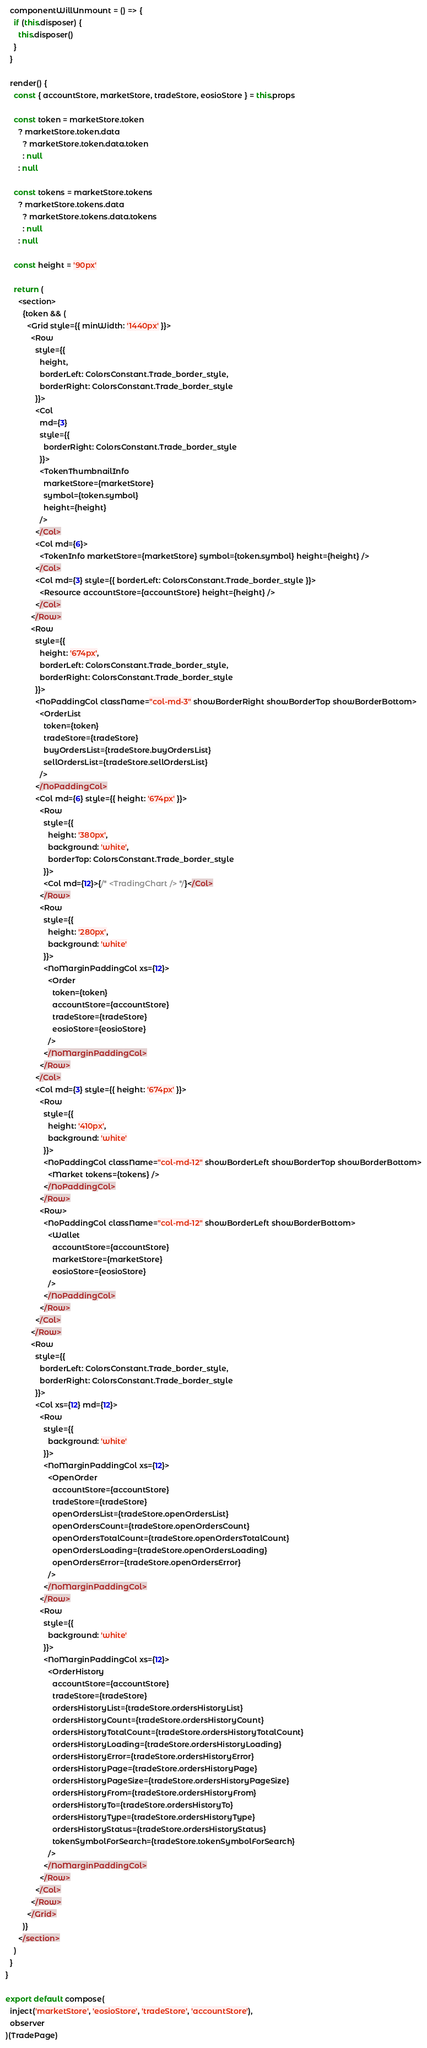Convert code to text. <code><loc_0><loc_0><loc_500><loc_500><_JavaScript_>  componentWillUnmount = () => {
    if (this.disposer) {
      this.disposer()
    }
  }

  render() {
    const { accountStore, marketStore, tradeStore, eosioStore } = this.props

    const token = marketStore.token
      ? marketStore.token.data
        ? marketStore.token.data.token
        : null
      : null

    const tokens = marketStore.tokens
      ? marketStore.tokens.data
        ? marketStore.tokens.data.tokens
        : null
      : null

    const height = '90px'

    return (
      <section>
        {token && (
          <Grid style={{ minWidth: '1440px' }}>
            <Row
              style={{
                height,
                borderLeft: ColorsConstant.Trade_border_style,
                borderRight: ColorsConstant.Trade_border_style
              }}>
              <Col
                md={3}
                style={{
                  borderRight: ColorsConstant.Trade_border_style
                }}>
                <TokenThumbnailInfo
                  marketStore={marketStore}
                  symbol={token.symbol}
                  height={height}
                />
              </Col>
              <Col md={6}>
                <TokenInfo marketStore={marketStore} symbol={token.symbol} height={height} />
              </Col>
              <Col md={3} style={{ borderLeft: ColorsConstant.Trade_border_style }}>
                <Resource accountStore={accountStore} height={height} />
              </Col>
            </Row>
            <Row
              style={{
                height: '674px',
                borderLeft: ColorsConstant.Trade_border_style,
                borderRight: ColorsConstant.Trade_border_style
              }}>
              <NoPaddingCol className="col-md-3" showBorderRight showBorderTop showBorderBottom>
                <OrderList
                  token={token}
                  tradeStore={tradeStore}
                  buyOrdersList={tradeStore.buyOrdersList}
                  sellOrdersList={tradeStore.sellOrdersList}
                />
              </NoPaddingCol>
              <Col md={6} style={{ height: '674px' }}>
                <Row
                  style={{
                    height: '380px',
                    background: 'white',
                    borderTop: ColorsConstant.Trade_border_style
                  }}>
                  <Col md={12}>{/* <TradingChart /> */}</Col>
                </Row>
                <Row
                  style={{
                    height: '280px',
                    background: 'white'
                  }}>
                  <NoMarginPaddingCol xs={12}>
                    <Order
                      token={token}
                      accountStore={accountStore}
                      tradeStore={tradeStore}
                      eosioStore={eosioStore}
                    />
                  </NoMarginPaddingCol>
                </Row>
              </Col>
              <Col md={3} style={{ height: '674px' }}>
                <Row
                  style={{
                    height: '410px',
                    background: 'white'
                  }}>
                  <NoPaddingCol className="col-md-12" showBorderLeft showBorderTop showBorderBottom>
                    <Market tokens={tokens} />
                  </NoPaddingCol>
                </Row>
                <Row>
                  <NoPaddingCol className="col-md-12" showBorderLeft showBorderBottom>
                    <Wallet
                      accountStore={accountStore}
                      marketStore={marketStore}
                      eosioStore={eosioStore}
                    />
                  </NoPaddingCol>
                </Row>
              </Col>
            </Row>
            <Row
              style={{
                borderLeft: ColorsConstant.Trade_border_style,
                borderRight: ColorsConstant.Trade_border_style
              }}>
              <Col xs={12} md={12}>
                <Row
                  style={{
                    background: 'white'
                  }}>
                  <NoMarginPaddingCol xs={12}>
                    <OpenOrder
                      accountStore={accountStore}
                      tradeStore={tradeStore}
                      openOrdersList={tradeStore.openOrdersList}
                      openOrdersCount={tradeStore.openOrdersCount}
                      openOrdersTotalCount={tradeStore.openOrdersTotalCount}
                      openOrdersLoading={tradeStore.openOrdersLoading}
                      openOrdersError={tradeStore.openOrdersError}
                    />
                  </NoMarginPaddingCol>
                </Row>
                <Row
                  style={{
                    background: 'white'
                  }}>
                  <NoMarginPaddingCol xs={12}>
                    <OrderHistory
                      accountStore={accountStore}
                      tradeStore={tradeStore}
                      ordersHistoryList={tradeStore.ordersHistoryList}
                      ordersHistoryCount={tradeStore.ordersHistoryCount}
                      ordersHistoryTotalCount={tradeStore.ordersHistoryTotalCount}
                      ordersHistoryLoading={tradeStore.ordersHistoryLoading}
                      ordersHistoryError={tradeStore.ordersHistoryError}
                      ordersHistoryPage={tradeStore.ordersHistoryPage}
                      ordersHistoryPageSize={tradeStore.ordersHistoryPageSize}
                      ordersHistoryFrom={tradeStore.ordersHistoryFrom}
                      ordersHistoryTo={tradeStore.ordersHistoryTo}
                      ordersHistoryType={tradeStore.ordersHistoryType}
                      ordersHistoryStatus={tradeStore.ordersHistoryStatus}
                      tokenSymbolForSearch={tradeStore.tokenSymbolForSearch}
                    />
                  </NoMarginPaddingCol>
                </Row>
              </Col>
            </Row>
          </Grid>
        )}
      </section>
    )
  }
}

export default compose(
  inject('marketStore', 'eosioStore', 'tradeStore', 'accountStore'),
  observer
)(TradePage)
</code> 